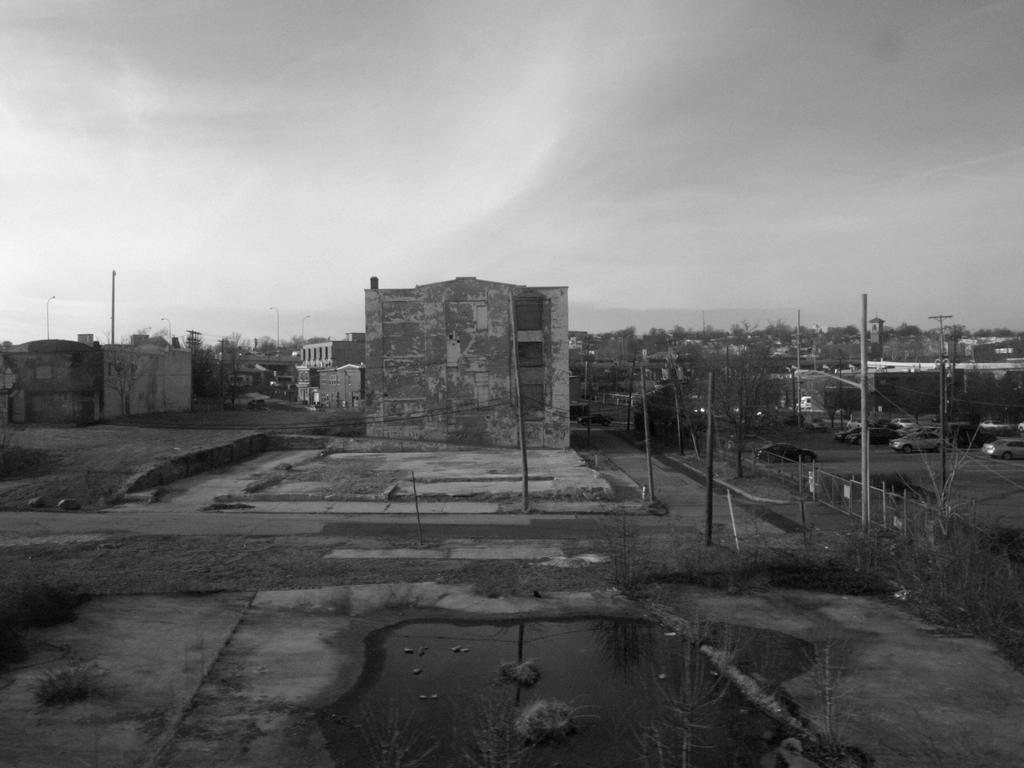Could you give a brief overview of what you see in this image? In this picture we can see some houses and some electric poles. 